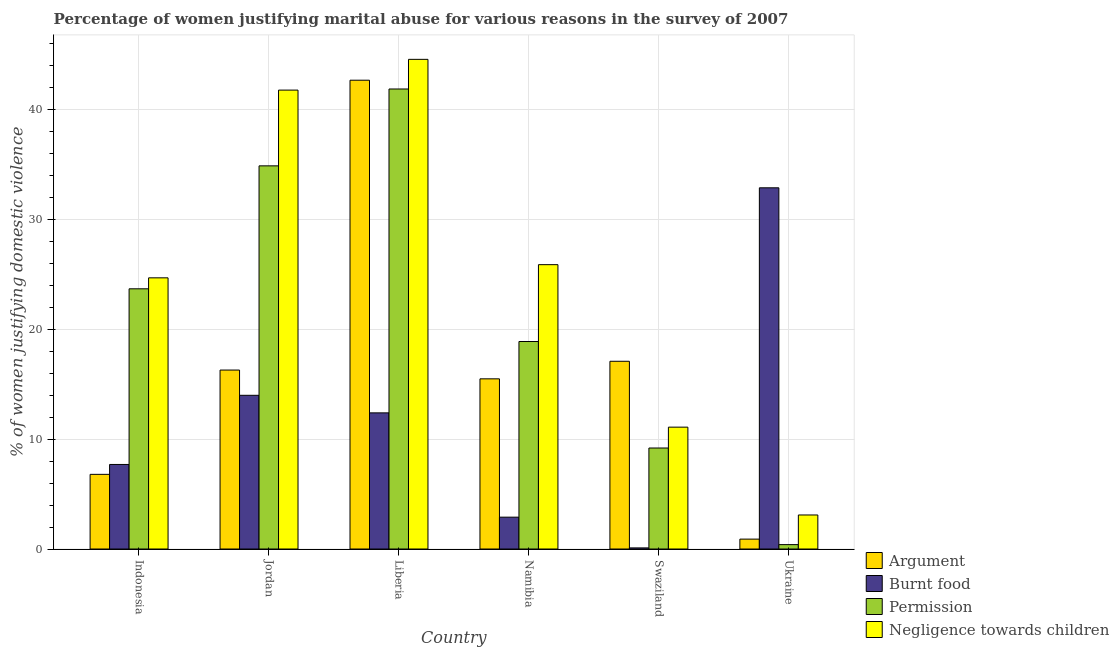How many bars are there on the 2nd tick from the right?
Offer a very short reply. 4. What is the label of the 4th group of bars from the left?
Give a very brief answer. Namibia. In how many cases, is the number of bars for a given country not equal to the number of legend labels?
Give a very brief answer. 0. What is the percentage of women justifying abuse for going without permission in Jordan?
Make the answer very short. 34.9. Across all countries, what is the maximum percentage of women justifying abuse for going without permission?
Offer a terse response. 41.9. In which country was the percentage of women justifying abuse for going without permission maximum?
Ensure brevity in your answer.  Liberia. In which country was the percentage of women justifying abuse for going without permission minimum?
Your response must be concise. Ukraine. What is the difference between the percentage of women justifying abuse for showing negligence towards children in Liberia and that in Ukraine?
Keep it short and to the point. 41.5. What is the difference between the percentage of women justifying abuse in the case of an argument in Jordan and the percentage of women justifying abuse for showing negligence towards children in Namibia?
Give a very brief answer. -9.6. What is the average percentage of women justifying abuse for showing negligence towards children per country?
Offer a terse response. 25.2. What is the difference between the percentage of women justifying abuse in the case of an argument and percentage of women justifying abuse for showing negligence towards children in Indonesia?
Ensure brevity in your answer.  -17.9. What is the ratio of the percentage of women justifying abuse for burning food in Jordan to that in Ukraine?
Your answer should be compact. 0.43. What is the difference between the highest and the second highest percentage of women justifying abuse for showing negligence towards children?
Offer a very short reply. 2.8. What is the difference between the highest and the lowest percentage of women justifying abuse for burning food?
Ensure brevity in your answer.  32.8. In how many countries, is the percentage of women justifying abuse for going without permission greater than the average percentage of women justifying abuse for going without permission taken over all countries?
Offer a very short reply. 3. Is the sum of the percentage of women justifying abuse for showing negligence towards children in Jordan and Ukraine greater than the maximum percentage of women justifying abuse in the case of an argument across all countries?
Your response must be concise. Yes. What does the 1st bar from the left in Liberia represents?
Your answer should be compact. Argument. What does the 2nd bar from the right in Indonesia represents?
Make the answer very short. Permission. Is it the case that in every country, the sum of the percentage of women justifying abuse in the case of an argument and percentage of women justifying abuse for burning food is greater than the percentage of women justifying abuse for going without permission?
Offer a very short reply. No. What is the difference between two consecutive major ticks on the Y-axis?
Make the answer very short. 10. Does the graph contain grids?
Your answer should be very brief. Yes. How many legend labels are there?
Your answer should be very brief. 4. What is the title of the graph?
Provide a short and direct response. Percentage of women justifying marital abuse for various reasons in the survey of 2007. Does "Greece" appear as one of the legend labels in the graph?
Your answer should be very brief. No. What is the label or title of the Y-axis?
Your answer should be compact. % of women justifying domestic violence. What is the % of women justifying domestic violence of Argument in Indonesia?
Your response must be concise. 6.8. What is the % of women justifying domestic violence of Burnt food in Indonesia?
Give a very brief answer. 7.7. What is the % of women justifying domestic violence in Permission in Indonesia?
Offer a very short reply. 23.7. What is the % of women justifying domestic violence in Negligence towards children in Indonesia?
Ensure brevity in your answer.  24.7. What is the % of women justifying domestic violence of Permission in Jordan?
Offer a very short reply. 34.9. What is the % of women justifying domestic violence in Negligence towards children in Jordan?
Give a very brief answer. 41.8. What is the % of women justifying domestic violence of Argument in Liberia?
Keep it short and to the point. 42.7. What is the % of women justifying domestic violence in Permission in Liberia?
Your answer should be compact. 41.9. What is the % of women justifying domestic violence of Negligence towards children in Liberia?
Make the answer very short. 44.6. What is the % of women justifying domestic violence in Argument in Namibia?
Ensure brevity in your answer.  15.5. What is the % of women justifying domestic violence in Burnt food in Namibia?
Your answer should be compact. 2.9. What is the % of women justifying domestic violence of Permission in Namibia?
Your response must be concise. 18.9. What is the % of women justifying domestic violence in Negligence towards children in Namibia?
Provide a succinct answer. 25.9. What is the % of women justifying domestic violence in Permission in Swaziland?
Make the answer very short. 9.2. What is the % of women justifying domestic violence in Negligence towards children in Swaziland?
Make the answer very short. 11.1. What is the % of women justifying domestic violence in Burnt food in Ukraine?
Keep it short and to the point. 32.9. What is the % of women justifying domestic violence in Negligence towards children in Ukraine?
Provide a succinct answer. 3.1. Across all countries, what is the maximum % of women justifying domestic violence in Argument?
Your answer should be compact. 42.7. Across all countries, what is the maximum % of women justifying domestic violence of Burnt food?
Your answer should be very brief. 32.9. Across all countries, what is the maximum % of women justifying domestic violence in Permission?
Make the answer very short. 41.9. Across all countries, what is the maximum % of women justifying domestic violence of Negligence towards children?
Offer a terse response. 44.6. Across all countries, what is the minimum % of women justifying domestic violence of Negligence towards children?
Your response must be concise. 3.1. What is the total % of women justifying domestic violence of Argument in the graph?
Offer a very short reply. 99.3. What is the total % of women justifying domestic violence in Burnt food in the graph?
Provide a short and direct response. 70. What is the total % of women justifying domestic violence in Permission in the graph?
Provide a short and direct response. 129. What is the total % of women justifying domestic violence of Negligence towards children in the graph?
Make the answer very short. 151.2. What is the difference between the % of women justifying domestic violence in Argument in Indonesia and that in Jordan?
Give a very brief answer. -9.5. What is the difference between the % of women justifying domestic violence of Burnt food in Indonesia and that in Jordan?
Keep it short and to the point. -6.3. What is the difference between the % of women justifying domestic violence in Permission in Indonesia and that in Jordan?
Provide a succinct answer. -11.2. What is the difference between the % of women justifying domestic violence of Negligence towards children in Indonesia and that in Jordan?
Provide a short and direct response. -17.1. What is the difference between the % of women justifying domestic violence in Argument in Indonesia and that in Liberia?
Offer a very short reply. -35.9. What is the difference between the % of women justifying domestic violence of Permission in Indonesia and that in Liberia?
Give a very brief answer. -18.2. What is the difference between the % of women justifying domestic violence of Negligence towards children in Indonesia and that in Liberia?
Your response must be concise. -19.9. What is the difference between the % of women justifying domestic violence of Argument in Indonesia and that in Namibia?
Offer a terse response. -8.7. What is the difference between the % of women justifying domestic violence in Permission in Indonesia and that in Namibia?
Ensure brevity in your answer.  4.8. What is the difference between the % of women justifying domestic violence of Argument in Indonesia and that in Swaziland?
Give a very brief answer. -10.3. What is the difference between the % of women justifying domestic violence in Permission in Indonesia and that in Swaziland?
Your answer should be compact. 14.5. What is the difference between the % of women justifying domestic violence in Negligence towards children in Indonesia and that in Swaziland?
Give a very brief answer. 13.6. What is the difference between the % of women justifying domestic violence of Argument in Indonesia and that in Ukraine?
Ensure brevity in your answer.  5.9. What is the difference between the % of women justifying domestic violence in Burnt food in Indonesia and that in Ukraine?
Provide a succinct answer. -25.2. What is the difference between the % of women justifying domestic violence of Permission in Indonesia and that in Ukraine?
Offer a very short reply. 23.3. What is the difference between the % of women justifying domestic violence in Negligence towards children in Indonesia and that in Ukraine?
Offer a terse response. 21.6. What is the difference between the % of women justifying domestic violence in Argument in Jordan and that in Liberia?
Provide a short and direct response. -26.4. What is the difference between the % of women justifying domestic violence of Burnt food in Jordan and that in Liberia?
Provide a short and direct response. 1.6. What is the difference between the % of women justifying domestic violence in Argument in Jordan and that in Namibia?
Make the answer very short. 0.8. What is the difference between the % of women justifying domestic violence in Burnt food in Jordan and that in Namibia?
Keep it short and to the point. 11.1. What is the difference between the % of women justifying domestic violence in Negligence towards children in Jordan and that in Namibia?
Keep it short and to the point. 15.9. What is the difference between the % of women justifying domestic violence in Argument in Jordan and that in Swaziland?
Your answer should be very brief. -0.8. What is the difference between the % of women justifying domestic violence in Permission in Jordan and that in Swaziland?
Offer a very short reply. 25.7. What is the difference between the % of women justifying domestic violence of Negligence towards children in Jordan and that in Swaziland?
Your response must be concise. 30.7. What is the difference between the % of women justifying domestic violence in Burnt food in Jordan and that in Ukraine?
Ensure brevity in your answer.  -18.9. What is the difference between the % of women justifying domestic violence in Permission in Jordan and that in Ukraine?
Your answer should be compact. 34.5. What is the difference between the % of women justifying domestic violence in Negligence towards children in Jordan and that in Ukraine?
Ensure brevity in your answer.  38.7. What is the difference between the % of women justifying domestic violence of Argument in Liberia and that in Namibia?
Provide a succinct answer. 27.2. What is the difference between the % of women justifying domestic violence of Burnt food in Liberia and that in Namibia?
Make the answer very short. 9.5. What is the difference between the % of women justifying domestic violence of Argument in Liberia and that in Swaziland?
Your response must be concise. 25.6. What is the difference between the % of women justifying domestic violence of Permission in Liberia and that in Swaziland?
Provide a succinct answer. 32.7. What is the difference between the % of women justifying domestic violence of Negligence towards children in Liberia and that in Swaziland?
Offer a terse response. 33.5. What is the difference between the % of women justifying domestic violence of Argument in Liberia and that in Ukraine?
Keep it short and to the point. 41.8. What is the difference between the % of women justifying domestic violence of Burnt food in Liberia and that in Ukraine?
Provide a succinct answer. -20.5. What is the difference between the % of women justifying domestic violence of Permission in Liberia and that in Ukraine?
Keep it short and to the point. 41.5. What is the difference between the % of women justifying domestic violence of Negligence towards children in Liberia and that in Ukraine?
Keep it short and to the point. 41.5. What is the difference between the % of women justifying domestic violence of Argument in Namibia and that in Swaziland?
Provide a short and direct response. -1.6. What is the difference between the % of women justifying domestic violence in Burnt food in Namibia and that in Swaziland?
Ensure brevity in your answer.  2.8. What is the difference between the % of women justifying domestic violence in Negligence towards children in Namibia and that in Swaziland?
Your answer should be very brief. 14.8. What is the difference between the % of women justifying domestic violence in Argument in Namibia and that in Ukraine?
Keep it short and to the point. 14.6. What is the difference between the % of women justifying domestic violence in Burnt food in Namibia and that in Ukraine?
Your answer should be very brief. -30. What is the difference between the % of women justifying domestic violence of Permission in Namibia and that in Ukraine?
Your response must be concise. 18.5. What is the difference between the % of women justifying domestic violence of Negligence towards children in Namibia and that in Ukraine?
Provide a succinct answer. 22.8. What is the difference between the % of women justifying domestic violence of Argument in Swaziland and that in Ukraine?
Offer a very short reply. 16.2. What is the difference between the % of women justifying domestic violence in Burnt food in Swaziland and that in Ukraine?
Provide a succinct answer. -32.8. What is the difference between the % of women justifying domestic violence of Argument in Indonesia and the % of women justifying domestic violence of Permission in Jordan?
Make the answer very short. -28.1. What is the difference between the % of women justifying domestic violence of Argument in Indonesia and the % of women justifying domestic violence of Negligence towards children in Jordan?
Ensure brevity in your answer.  -35. What is the difference between the % of women justifying domestic violence of Burnt food in Indonesia and the % of women justifying domestic violence of Permission in Jordan?
Give a very brief answer. -27.2. What is the difference between the % of women justifying domestic violence in Burnt food in Indonesia and the % of women justifying domestic violence in Negligence towards children in Jordan?
Ensure brevity in your answer.  -34.1. What is the difference between the % of women justifying domestic violence in Permission in Indonesia and the % of women justifying domestic violence in Negligence towards children in Jordan?
Make the answer very short. -18.1. What is the difference between the % of women justifying domestic violence in Argument in Indonesia and the % of women justifying domestic violence in Burnt food in Liberia?
Ensure brevity in your answer.  -5.6. What is the difference between the % of women justifying domestic violence of Argument in Indonesia and the % of women justifying domestic violence of Permission in Liberia?
Offer a terse response. -35.1. What is the difference between the % of women justifying domestic violence in Argument in Indonesia and the % of women justifying domestic violence in Negligence towards children in Liberia?
Offer a very short reply. -37.8. What is the difference between the % of women justifying domestic violence of Burnt food in Indonesia and the % of women justifying domestic violence of Permission in Liberia?
Provide a short and direct response. -34.2. What is the difference between the % of women justifying domestic violence of Burnt food in Indonesia and the % of women justifying domestic violence of Negligence towards children in Liberia?
Your answer should be very brief. -36.9. What is the difference between the % of women justifying domestic violence of Permission in Indonesia and the % of women justifying domestic violence of Negligence towards children in Liberia?
Provide a succinct answer. -20.9. What is the difference between the % of women justifying domestic violence in Argument in Indonesia and the % of women justifying domestic violence in Negligence towards children in Namibia?
Keep it short and to the point. -19.1. What is the difference between the % of women justifying domestic violence in Burnt food in Indonesia and the % of women justifying domestic violence in Negligence towards children in Namibia?
Give a very brief answer. -18.2. What is the difference between the % of women justifying domestic violence in Argument in Indonesia and the % of women justifying domestic violence in Burnt food in Swaziland?
Your answer should be compact. 6.7. What is the difference between the % of women justifying domestic violence of Argument in Indonesia and the % of women justifying domestic violence of Negligence towards children in Swaziland?
Ensure brevity in your answer.  -4.3. What is the difference between the % of women justifying domestic violence in Burnt food in Indonesia and the % of women justifying domestic violence in Permission in Swaziland?
Provide a short and direct response. -1.5. What is the difference between the % of women justifying domestic violence in Burnt food in Indonesia and the % of women justifying domestic violence in Negligence towards children in Swaziland?
Offer a terse response. -3.4. What is the difference between the % of women justifying domestic violence of Permission in Indonesia and the % of women justifying domestic violence of Negligence towards children in Swaziland?
Offer a terse response. 12.6. What is the difference between the % of women justifying domestic violence in Argument in Indonesia and the % of women justifying domestic violence in Burnt food in Ukraine?
Your answer should be very brief. -26.1. What is the difference between the % of women justifying domestic violence in Argument in Indonesia and the % of women justifying domestic violence in Permission in Ukraine?
Offer a very short reply. 6.4. What is the difference between the % of women justifying domestic violence in Argument in Indonesia and the % of women justifying domestic violence in Negligence towards children in Ukraine?
Your answer should be very brief. 3.7. What is the difference between the % of women justifying domestic violence in Burnt food in Indonesia and the % of women justifying domestic violence in Negligence towards children in Ukraine?
Offer a very short reply. 4.6. What is the difference between the % of women justifying domestic violence in Permission in Indonesia and the % of women justifying domestic violence in Negligence towards children in Ukraine?
Your answer should be compact. 20.6. What is the difference between the % of women justifying domestic violence of Argument in Jordan and the % of women justifying domestic violence of Permission in Liberia?
Offer a very short reply. -25.6. What is the difference between the % of women justifying domestic violence in Argument in Jordan and the % of women justifying domestic violence in Negligence towards children in Liberia?
Ensure brevity in your answer.  -28.3. What is the difference between the % of women justifying domestic violence in Burnt food in Jordan and the % of women justifying domestic violence in Permission in Liberia?
Your answer should be very brief. -27.9. What is the difference between the % of women justifying domestic violence of Burnt food in Jordan and the % of women justifying domestic violence of Negligence towards children in Liberia?
Your response must be concise. -30.6. What is the difference between the % of women justifying domestic violence of Permission in Jordan and the % of women justifying domestic violence of Negligence towards children in Liberia?
Your answer should be very brief. -9.7. What is the difference between the % of women justifying domestic violence in Argument in Jordan and the % of women justifying domestic violence in Burnt food in Namibia?
Your answer should be very brief. 13.4. What is the difference between the % of women justifying domestic violence of Argument in Jordan and the % of women justifying domestic violence of Negligence towards children in Namibia?
Your answer should be compact. -9.6. What is the difference between the % of women justifying domestic violence of Burnt food in Jordan and the % of women justifying domestic violence of Permission in Namibia?
Your answer should be compact. -4.9. What is the difference between the % of women justifying domestic violence in Burnt food in Jordan and the % of women justifying domestic violence in Negligence towards children in Namibia?
Make the answer very short. -11.9. What is the difference between the % of women justifying domestic violence of Argument in Jordan and the % of women justifying domestic violence of Negligence towards children in Swaziland?
Ensure brevity in your answer.  5.2. What is the difference between the % of women justifying domestic violence of Burnt food in Jordan and the % of women justifying domestic violence of Permission in Swaziland?
Ensure brevity in your answer.  4.8. What is the difference between the % of women justifying domestic violence of Permission in Jordan and the % of women justifying domestic violence of Negligence towards children in Swaziland?
Keep it short and to the point. 23.8. What is the difference between the % of women justifying domestic violence of Argument in Jordan and the % of women justifying domestic violence of Burnt food in Ukraine?
Ensure brevity in your answer.  -16.6. What is the difference between the % of women justifying domestic violence of Argument in Jordan and the % of women justifying domestic violence of Permission in Ukraine?
Your answer should be compact. 15.9. What is the difference between the % of women justifying domestic violence of Burnt food in Jordan and the % of women justifying domestic violence of Permission in Ukraine?
Your answer should be very brief. 13.6. What is the difference between the % of women justifying domestic violence of Permission in Jordan and the % of women justifying domestic violence of Negligence towards children in Ukraine?
Provide a succinct answer. 31.8. What is the difference between the % of women justifying domestic violence of Argument in Liberia and the % of women justifying domestic violence of Burnt food in Namibia?
Make the answer very short. 39.8. What is the difference between the % of women justifying domestic violence of Argument in Liberia and the % of women justifying domestic violence of Permission in Namibia?
Give a very brief answer. 23.8. What is the difference between the % of women justifying domestic violence in Argument in Liberia and the % of women justifying domestic violence in Burnt food in Swaziland?
Offer a very short reply. 42.6. What is the difference between the % of women justifying domestic violence of Argument in Liberia and the % of women justifying domestic violence of Permission in Swaziland?
Give a very brief answer. 33.5. What is the difference between the % of women justifying domestic violence of Argument in Liberia and the % of women justifying domestic violence of Negligence towards children in Swaziland?
Ensure brevity in your answer.  31.6. What is the difference between the % of women justifying domestic violence of Burnt food in Liberia and the % of women justifying domestic violence of Permission in Swaziland?
Your answer should be very brief. 3.2. What is the difference between the % of women justifying domestic violence in Burnt food in Liberia and the % of women justifying domestic violence in Negligence towards children in Swaziland?
Ensure brevity in your answer.  1.3. What is the difference between the % of women justifying domestic violence of Permission in Liberia and the % of women justifying domestic violence of Negligence towards children in Swaziland?
Your response must be concise. 30.8. What is the difference between the % of women justifying domestic violence of Argument in Liberia and the % of women justifying domestic violence of Permission in Ukraine?
Offer a terse response. 42.3. What is the difference between the % of women justifying domestic violence in Argument in Liberia and the % of women justifying domestic violence in Negligence towards children in Ukraine?
Your response must be concise. 39.6. What is the difference between the % of women justifying domestic violence of Burnt food in Liberia and the % of women justifying domestic violence of Permission in Ukraine?
Offer a terse response. 12. What is the difference between the % of women justifying domestic violence in Burnt food in Liberia and the % of women justifying domestic violence in Negligence towards children in Ukraine?
Give a very brief answer. 9.3. What is the difference between the % of women justifying domestic violence in Permission in Liberia and the % of women justifying domestic violence in Negligence towards children in Ukraine?
Your answer should be compact. 38.8. What is the difference between the % of women justifying domestic violence of Argument in Namibia and the % of women justifying domestic violence of Burnt food in Swaziland?
Make the answer very short. 15.4. What is the difference between the % of women justifying domestic violence of Argument in Namibia and the % of women justifying domestic violence of Negligence towards children in Swaziland?
Your response must be concise. 4.4. What is the difference between the % of women justifying domestic violence in Burnt food in Namibia and the % of women justifying domestic violence in Permission in Swaziland?
Offer a terse response. -6.3. What is the difference between the % of women justifying domestic violence of Argument in Namibia and the % of women justifying domestic violence of Burnt food in Ukraine?
Your answer should be very brief. -17.4. What is the difference between the % of women justifying domestic violence in Permission in Namibia and the % of women justifying domestic violence in Negligence towards children in Ukraine?
Your answer should be very brief. 15.8. What is the difference between the % of women justifying domestic violence in Argument in Swaziland and the % of women justifying domestic violence in Burnt food in Ukraine?
Your response must be concise. -15.8. What is the difference between the % of women justifying domestic violence of Burnt food in Swaziland and the % of women justifying domestic violence of Permission in Ukraine?
Your answer should be very brief. -0.3. What is the difference between the % of women justifying domestic violence in Permission in Swaziland and the % of women justifying domestic violence in Negligence towards children in Ukraine?
Offer a terse response. 6.1. What is the average % of women justifying domestic violence in Argument per country?
Offer a very short reply. 16.55. What is the average % of women justifying domestic violence in Burnt food per country?
Provide a short and direct response. 11.67. What is the average % of women justifying domestic violence in Permission per country?
Your answer should be very brief. 21.5. What is the average % of women justifying domestic violence of Negligence towards children per country?
Give a very brief answer. 25.2. What is the difference between the % of women justifying domestic violence of Argument and % of women justifying domestic violence of Burnt food in Indonesia?
Your answer should be very brief. -0.9. What is the difference between the % of women justifying domestic violence of Argument and % of women justifying domestic violence of Permission in Indonesia?
Provide a short and direct response. -16.9. What is the difference between the % of women justifying domestic violence in Argument and % of women justifying domestic violence in Negligence towards children in Indonesia?
Provide a succinct answer. -17.9. What is the difference between the % of women justifying domestic violence in Permission and % of women justifying domestic violence in Negligence towards children in Indonesia?
Offer a very short reply. -1. What is the difference between the % of women justifying domestic violence in Argument and % of women justifying domestic violence in Permission in Jordan?
Give a very brief answer. -18.6. What is the difference between the % of women justifying domestic violence of Argument and % of women justifying domestic violence of Negligence towards children in Jordan?
Ensure brevity in your answer.  -25.5. What is the difference between the % of women justifying domestic violence of Burnt food and % of women justifying domestic violence of Permission in Jordan?
Your response must be concise. -20.9. What is the difference between the % of women justifying domestic violence in Burnt food and % of women justifying domestic violence in Negligence towards children in Jordan?
Offer a terse response. -27.8. What is the difference between the % of women justifying domestic violence of Argument and % of women justifying domestic violence of Burnt food in Liberia?
Give a very brief answer. 30.3. What is the difference between the % of women justifying domestic violence of Burnt food and % of women justifying domestic violence of Permission in Liberia?
Make the answer very short. -29.5. What is the difference between the % of women justifying domestic violence in Burnt food and % of women justifying domestic violence in Negligence towards children in Liberia?
Give a very brief answer. -32.2. What is the difference between the % of women justifying domestic violence of Argument and % of women justifying domestic violence of Burnt food in Namibia?
Provide a succinct answer. 12.6. What is the difference between the % of women justifying domestic violence of Argument and % of women justifying domestic violence of Permission in Namibia?
Ensure brevity in your answer.  -3.4. What is the difference between the % of women justifying domestic violence in Burnt food and % of women justifying domestic violence in Permission in Namibia?
Offer a very short reply. -16. What is the difference between the % of women justifying domestic violence in Burnt food and % of women justifying domestic violence in Negligence towards children in Namibia?
Offer a very short reply. -23. What is the difference between the % of women justifying domestic violence of Permission and % of women justifying domestic violence of Negligence towards children in Namibia?
Ensure brevity in your answer.  -7. What is the difference between the % of women justifying domestic violence of Argument and % of women justifying domestic violence of Burnt food in Swaziland?
Make the answer very short. 17. What is the difference between the % of women justifying domestic violence of Argument and % of women justifying domestic violence of Negligence towards children in Swaziland?
Keep it short and to the point. 6. What is the difference between the % of women justifying domestic violence of Burnt food and % of women justifying domestic violence of Permission in Swaziland?
Offer a terse response. -9.1. What is the difference between the % of women justifying domestic violence of Burnt food and % of women justifying domestic violence of Negligence towards children in Swaziland?
Keep it short and to the point. -11. What is the difference between the % of women justifying domestic violence of Argument and % of women justifying domestic violence of Burnt food in Ukraine?
Your answer should be very brief. -32. What is the difference between the % of women justifying domestic violence in Argument and % of women justifying domestic violence in Negligence towards children in Ukraine?
Keep it short and to the point. -2.2. What is the difference between the % of women justifying domestic violence in Burnt food and % of women justifying domestic violence in Permission in Ukraine?
Give a very brief answer. 32.5. What is the difference between the % of women justifying domestic violence of Burnt food and % of women justifying domestic violence of Negligence towards children in Ukraine?
Provide a short and direct response. 29.8. What is the difference between the % of women justifying domestic violence in Permission and % of women justifying domestic violence in Negligence towards children in Ukraine?
Your response must be concise. -2.7. What is the ratio of the % of women justifying domestic violence of Argument in Indonesia to that in Jordan?
Your answer should be very brief. 0.42. What is the ratio of the % of women justifying domestic violence of Burnt food in Indonesia to that in Jordan?
Keep it short and to the point. 0.55. What is the ratio of the % of women justifying domestic violence in Permission in Indonesia to that in Jordan?
Provide a succinct answer. 0.68. What is the ratio of the % of women justifying domestic violence of Negligence towards children in Indonesia to that in Jordan?
Provide a short and direct response. 0.59. What is the ratio of the % of women justifying domestic violence of Argument in Indonesia to that in Liberia?
Keep it short and to the point. 0.16. What is the ratio of the % of women justifying domestic violence in Burnt food in Indonesia to that in Liberia?
Offer a very short reply. 0.62. What is the ratio of the % of women justifying domestic violence of Permission in Indonesia to that in Liberia?
Provide a succinct answer. 0.57. What is the ratio of the % of women justifying domestic violence in Negligence towards children in Indonesia to that in Liberia?
Offer a very short reply. 0.55. What is the ratio of the % of women justifying domestic violence in Argument in Indonesia to that in Namibia?
Your answer should be very brief. 0.44. What is the ratio of the % of women justifying domestic violence in Burnt food in Indonesia to that in Namibia?
Offer a very short reply. 2.66. What is the ratio of the % of women justifying domestic violence in Permission in Indonesia to that in Namibia?
Make the answer very short. 1.25. What is the ratio of the % of women justifying domestic violence in Negligence towards children in Indonesia to that in Namibia?
Your answer should be very brief. 0.95. What is the ratio of the % of women justifying domestic violence in Argument in Indonesia to that in Swaziland?
Provide a short and direct response. 0.4. What is the ratio of the % of women justifying domestic violence in Burnt food in Indonesia to that in Swaziland?
Your response must be concise. 77. What is the ratio of the % of women justifying domestic violence in Permission in Indonesia to that in Swaziland?
Provide a short and direct response. 2.58. What is the ratio of the % of women justifying domestic violence in Negligence towards children in Indonesia to that in Swaziland?
Make the answer very short. 2.23. What is the ratio of the % of women justifying domestic violence in Argument in Indonesia to that in Ukraine?
Your response must be concise. 7.56. What is the ratio of the % of women justifying domestic violence in Burnt food in Indonesia to that in Ukraine?
Keep it short and to the point. 0.23. What is the ratio of the % of women justifying domestic violence in Permission in Indonesia to that in Ukraine?
Give a very brief answer. 59.25. What is the ratio of the % of women justifying domestic violence in Negligence towards children in Indonesia to that in Ukraine?
Give a very brief answer. 7.97. What is the ratio of the % of women justifying domestic violence in Argument in Jordan to that in Liberia?
Make the answer very short. 0.38. What is the ratio of the % of women justifying domestic violence in Burnt food in Jordan to that in Liberia?
Offer a terse response. 1.13. What is the ratio of the % of women justifying domestic violence in Permission in Jordan to that in Liberia?
Your answer should be compact. 0.83. What is the ratio of the % of women justifying domestic violence of Negligence towards children in Jordan to that in Liberia?
Ensure brevity in your answer.  0.94. What is the ratio of the % of women justifying domestic violence of Argument in Jordan to that in Namibia?
Your answer should be very brief. 1.05. What is the ratio of the % of women justifying domestic violence of Burnt food in Jordan to that in Namibia?
Offer a terse response. 4.83. What is the ratio of the % of women justifying domestic violence in Permission in Jordan to that in Namibia?
Give a very brief answer. 1.85. What is the ratio of the % of women justifying domestic violence in Negligence towards children in Jordan to that in Namibia?
Make the answer very short. 1.61. What is the ratio of the % of women justifying domestic violence in Argument in Jordan to that in Swaziland?
Keep it short and to the point. 0.95. What is the ratio of the % of women justifying domestic violence in Burnt food in Jordan to that in Swaziland?
Ensure brevity in your answer.  140. What is the ratio of the % of women justifying domestic violence in Permission in Jordan to that in Swaziland?
Give a very brief answer. 3.79. What is the ratio of the % of women justifying domestic violence in Negligence towards children in Jordan to that in Swaziland?
Make the answer very short. 3.77. What is the ratio of the % of women justifying domestic violence in Argument in Jordan to that in Ukraine?
Your response must be concise. 18.11. What is the ratio of the % of women justifying domestic violence in Burnt food in Jordan to that in Ukraine?
Offer a very short reply. 0.43. What is the ratio of the % of women justifying domestic violence in Permission in Jordan to that in Ukraine?
Your response must be concise. 87.25. What is the ratio of the % of women justifying domestic violence of Negligence towards children in Jordan to that in Ukraine?
Your answer should be very brief. 13.48. What is the ratio of the % of women justifying domestic violence in Argument in Liberia to that in Namibia?
Keep it short and to the point. 2.75. What is the ratio of the % of women justifying domestic violence in Burnt food in Liberia to that in Namibia?
Offer a terse response. 4.28. What is the ratio of the % of women justifying domestic violence of Permission in Liberia to that in Namibia?
Offer a very short reply. 2.22. What is the ratio of the % of women justifying domestic violence of Negligence towards children in Liberia to that in Namibia?
Offer a terse response. 1.72. What is the ratio of the % of women justifying domestic violence of Argument in Liberia to that in Swaziland?
Your response must be concise. 2.5. What is the ratio of the % of women justifying domestic violence of Burnt food in Liberia to that in Swaziland?
Provide a succinct answer. 124. What is the ratio of the % of women justifying domestic violence of Permission in Liberia to that in Swaziland?
Keep it short and to the point. 4.55. What is the ratio of the % of women justifying domestic violence of Negligence towards children in Liberia to that in Swaziland?
Your answer should be very brief. 4.02. What is the ratio of the % of women justifying domestic violence of Argument in Liberia to that in Ukraine?
Your answer should be very brief. 47.44. What is the ratio of the % of women justifying domestic violence in Burnt food in Liberia to that in Ukraine?
Make the answer very short. 0.38. What is the ratio of the % of women justifying domestic violence in Permission in Liberia to that in Ukraine?
Offer a very short reply. 104.75. What is the ratio of the % of women justifying domestic violence in Negligence towards children in Liberia to that in Ukraine?
Provide a succinct answer. 14.39. What is the ratio of the % of women justifying domestic violence of Argument in Namibia to that in Swaziland?
Your answer should be compact. 0.91. What is the ratio of the % of women justifying domestic violence of Permission in Namibia to that in Swaziland?
Your answer should be compact. 2.05. What is the ratio of the % of women justifying domestic violence of Negligence towards children in Namibia to that in Swaziland?
Keep it short and to the point. 2.33. What is the ratio of the % of women justifying domestic violence in Argument in Namibia to that in Ukraine?
Keep it short and to the point. 17.22. What is the ratio of the % of women justifying domestic violence of Burnt food in Namibia to that in Ukraine?
Offer a very short reply. 0.09. What is the ratio of the % of women justifying domestic violence of Permission in Namibia to that in Ukraine?
Your answer should be compact. 47.25. What is the ratio of the % of women justifying domestic violence in Negligence towards children in Namibia to that in Ukraine?
Ensure brevity in your answer.  8.35. What is the ratio of the % of women justifying domestic violence of Burnt food in Swaziland to that in Ukraine?
Your answer should be compact. 0. What is the ratio of the % of women justifying domestic violence of Negligence towards children in Swaziland to that in Ukraine?
Keep it short and to the point. 3.58. What is the difference between the highest and the second highest % of women justifying domestic violence in Argument?
Keep it short and to the point. 25.6. What is the difference between the highest and the second highest % of women justifying domestic violence in Permission?
Keep it short and to the point. 7. What is the difference between the highest and the second highest % of women justifying domestic violence in Negligence towards children?
Offer a very short reply. 2.8. What is the difference between the highest and the lowest % of women justifying domestic violence of Argument?
Provide a short and direct response. 41.8. What is the difference between the highest and the lowest % of women justifying domestic violence of Burnt food?
Your answer should be compact. 32.8. What is the difference between the highest and the lowest % of women justifying domestic violence of Permission?
Ensure brevity in your answer.  41.5. What is the difference between the highest and the lowest % of women justifying domestic violence of Negligence towards children?
Provide a succinct answer. 41.5. 